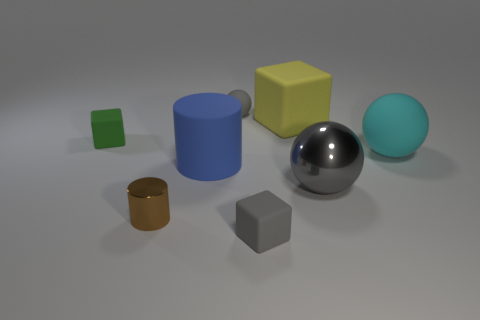How many other things are the same shape as the large gray thing?
Keep it short and to the point. 2. What is the shape of the small gray matte object that is behind the blue cylinder?
Make the answer very short. Sphere. There is a tiny green object; is its shape the same as the small matte thing in front of the big cylinder?
Your answer should be compact. Yes. What size is the rubber object that is in front of the large cyan matte sphere and behind the brown object?
Keep it short and to the point. Large. There is a rubber cube that is both behind the tiny metallic cylinder and left of the big yellow block; what is its color?
Your response must be concise. Green. Are there any other things that are the same material as the cyan sphere?
Make the answer very short. Yes. Is the number of big blue matte cylinders behind the big gray sphere less than the number of cyan rubber balls on the left side of the tiny metallic cylinder?
Your answer should be very brief. No. Is there any other thing that is the same color as the large cube?
Offer a terse response. No. What is the shape of the tiny metal object?
Ensure brevity in your answer.  Cylinder. The large sphere that is made of the same material as the tiny gray ball is what color?
Your answer should be compact. Cyan. 